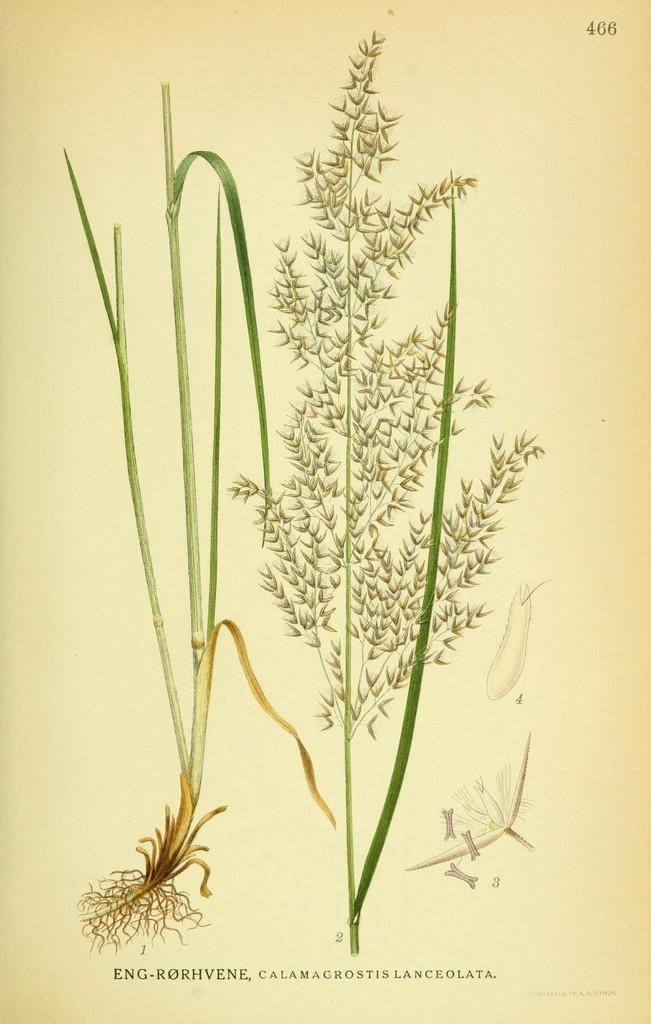What is depicted on the paper in the image? There are pictures of grass types on a paper in the image. What type of pencil does the mother use to draw the grass types in the image? There is no mother or pencil present in the image; it only shows pictures of grass types on a paper. 